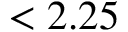Convert formula to latex. <formula><loc_0><loc_0><loc_500><loc_500>< 2 . 2 5</formula> 